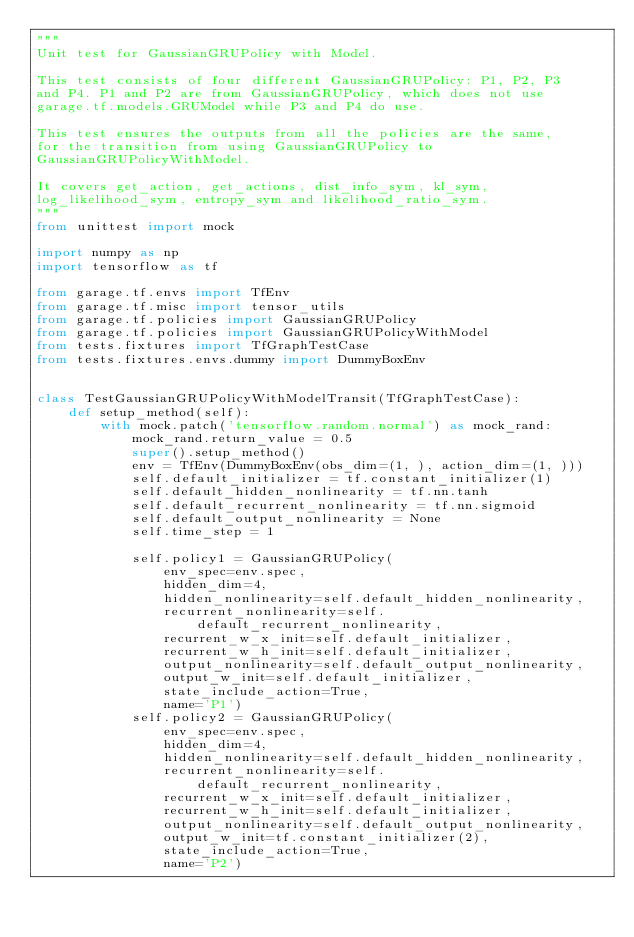<code> <loc_0><loc_0><loc_500><loc_500><_Python_>"""
Unit test for GaussianGRUPolicy with Model.

This test consists of four different GaussianGRUPolicy: P1, P2, P3
and P4. P1 and P2 are from GaussianGRUPolicy, which does not use
garage.tf.models.GRUModel while P3 and P4 do use.

This test ensures the outputs from all the policies are the same,
for the transition from using GaussianGRUPolicy to
GaussianGRUPolicyWithModel.

It covers get_action, get_actions, dist_info_sym, kl_sym,
log_likelihood_sym, entropy_sym and likelihood_ratio_sym.
"""
from unittest import mock

import numpy as np
import tensorflow as tf

from garage.tf.envs import TfEnv
from garage.tf.misc import tensor_utils
from garage.tf.policies import GaussianGRUPolicy
from garage.tf.policies import GaussianGRUPolicyWithModel
from tests.fixtures import TfGraphTestCase
from tests.fixtures.envs.dummy import DummyBoxEnv


class TestGaussianGRUPolicyWithModelTransit(TfGraphTestCase):
    def setup_method(self):
        with mock.patch('tensorflow.random.normal') as mock_rand:
            mock_rand.return_value = 0.5
            super().setup_method()
            env = TfEnv(DummyBoxEnv(obs_dim=(1, ), action_dim=(1, )))
            self.default_initializer = tf.constant_initializer(1)
            self.default_hidden_nonlinearity = tf.nn.tanh
            self.default_recurrent_nonlinearity = tf.nn.sigmoid
            self.default_output_nonlinearity = None
            self.time_step = 1

            self.policy1 = GaussianGRUPolicy(
                env_spec=env.spec,
                hidden_dim=4,
                hidden_nonlinearity=self.default_hidden_nonlinearity,
                recurrent_nonlinearity=self.default_recurrent_nonlinearity,
                recurrent_w_x_init=self.default_initializer,
                recurrent_w_h_init=self.default_initializer,
                output_nonlinearity=self.default_output_nonlinearity,
                output_w_init=self.default_initializer,
                state_include_action=True,
                name='P1')
            self.policy2 = GaussianGRUPolicy(
                env_spec=env.spec,
                hidden_dim=4,
                hidden_nonlinearity=self.default_hidden_nonlinearity,
                recurrent_nonlinearity=self.default_recurrent_nonlinearity,
                recurrent_w_x_init=self.default_initializer,
                recurrent_w_h_init=self.default_initializer,
                output_nonlinearity=self.default_output_nonlinearity,
                output_w_init=tf.constant_initializer(2),
                state_include_action=True,
                name='P2')
</code> 